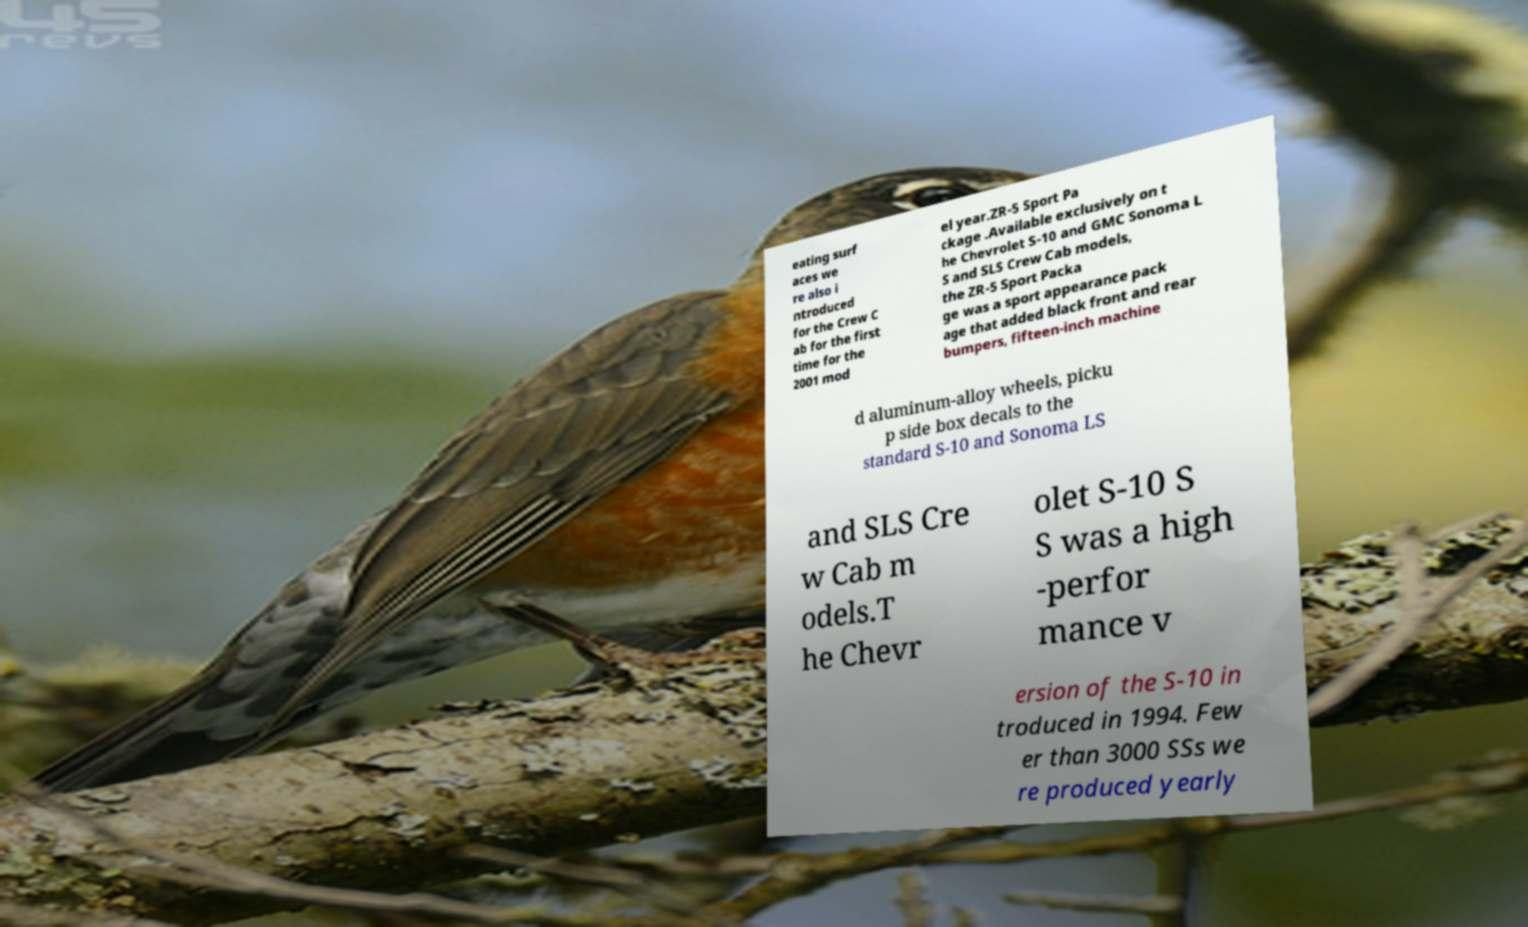Can you read and provide the text displayed in the image?This photo seems to have some interesting text. Can you extract and type it out for me? eating surf aces we re also i ntroduced for the Crew C ab for the first time for the 2001 mod el year.ZR-5 Sport Pa ckage .Available exclusively on t he Chevrolet S-10 and GMC Sonoma L S and SLS Crew Cab models, the ZR-5 Sport Packa ge was a sport appearance pack age that added black front and rear bumpers, fifteen-inch machine d aluminum-alloy wheels, picku p side box decals to the standard S-10 and Sonoma LS and SLS Cre w Cab m odels.T he Chevr olet S-10 S S was a high -perfor mance v ersion of the S-10 in troduced in 1994. Few er than 3000 SSs we re produced yearly 